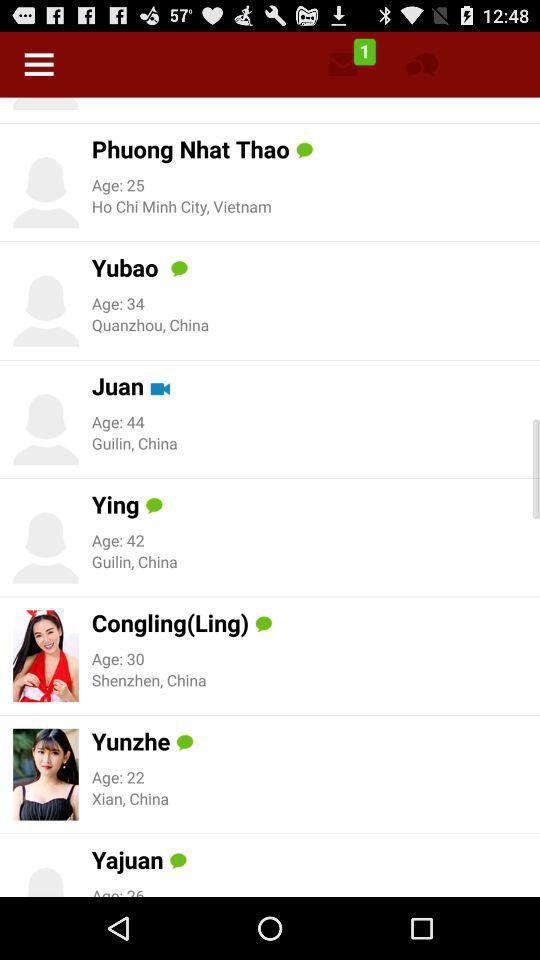What is the age of Phuong Nhat Thao? The age is 25. 